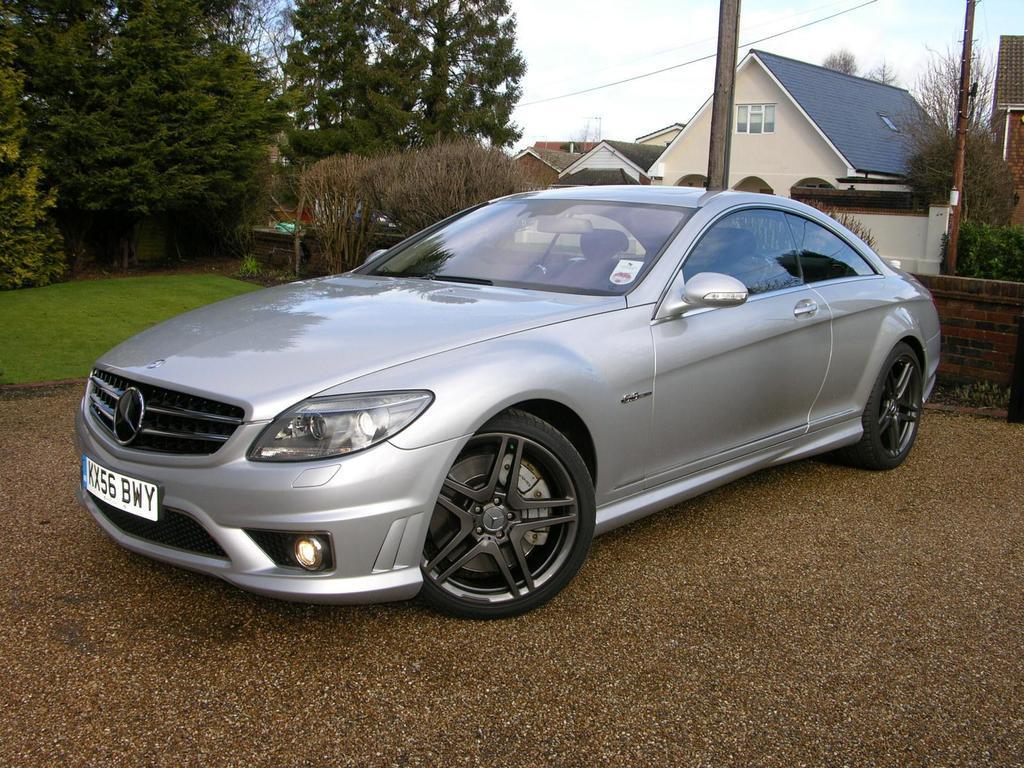Could you give a brief overview of what you see in this image? In the center of the image we can see a vehicle with number plate parked on the. On the left side of the image we can see the grass and a group of trees. On the right side of the image we can see buildings with windows and roofs, we can also see some plants and poles. At the top of the image we can see a cable and the sky. 